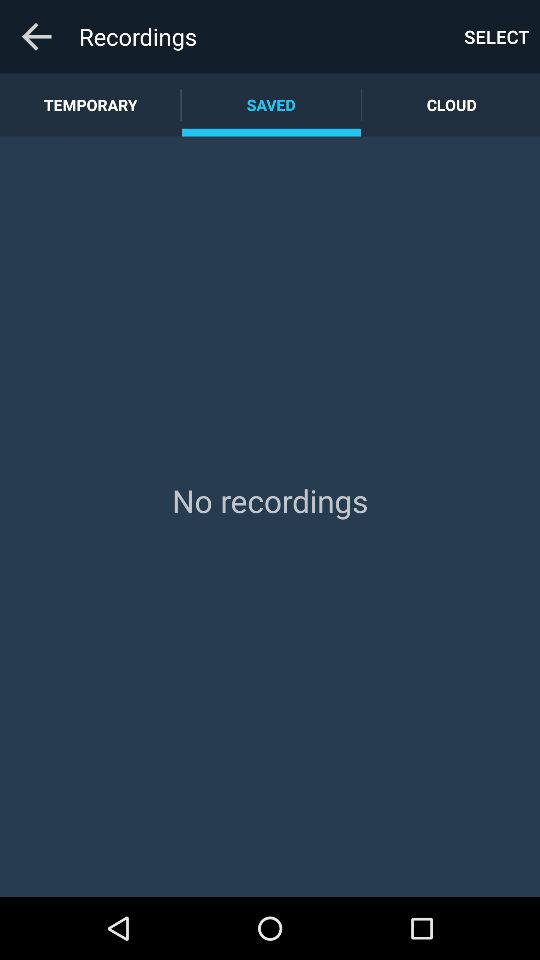Which tab has been selected? The selected tab is "SAVED". 